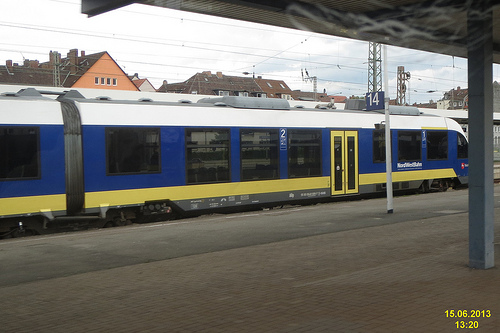Are there buses or cars in this photo? From this angle, we cannot see any buses or cars; the primary focus is the train and the platform. 